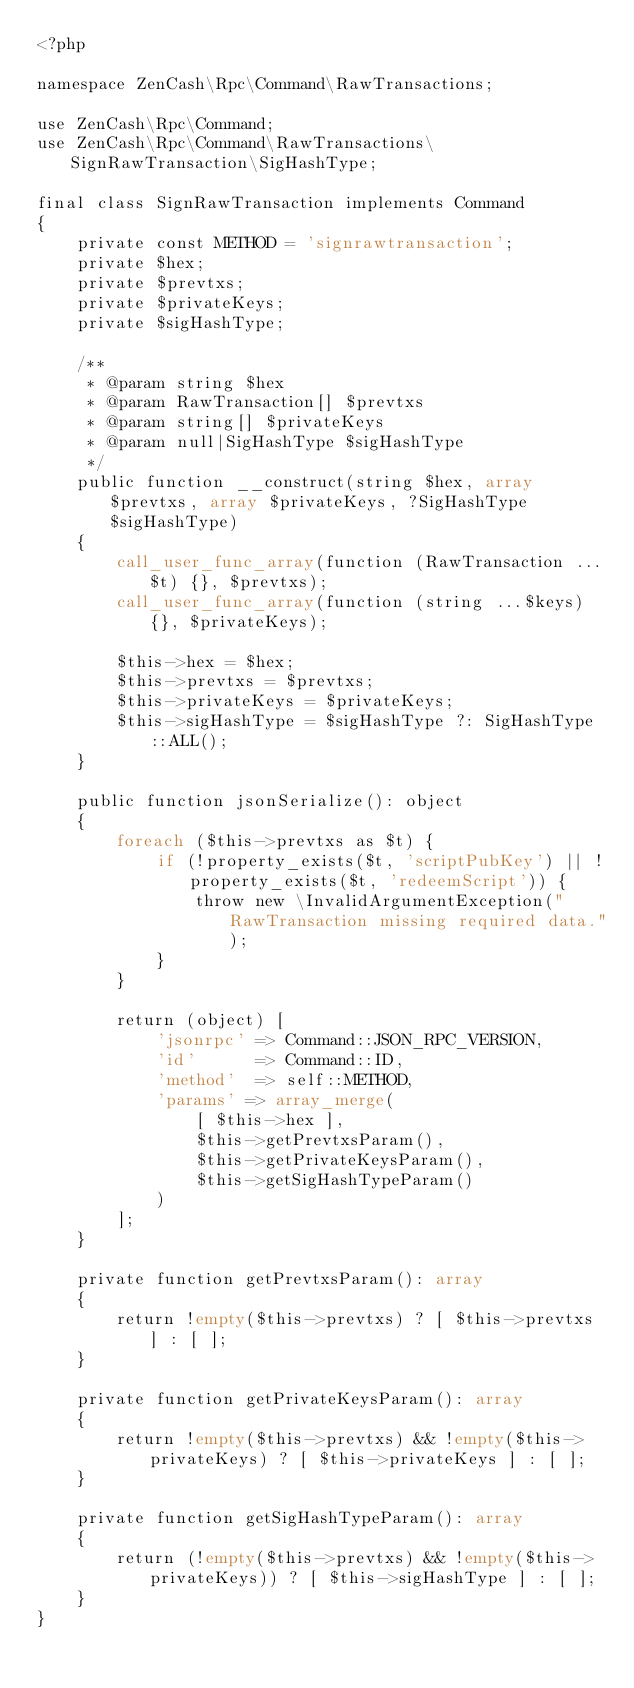Convert code to text. <code><loc_0><loc_0><loc_500><loc_500><_PHP_><?php

namespace ZenCash\Rpc\Command\RawTransactions;

use ZenCash\Rpc\Command;
use ZenCash\Rpc\Command\RawTransactions\SignRawTransaction\SigHashType;

final class SignRawTransaction implements Command
{
    private const METHOD = 'signrawtransaction';
    private $hex;
    private $prevtxs;
    private $privateKeys;
    private $sigHashType;

    /**
     * @param string $hex
     * @param RawTransaction[] $prevtxs
     * @param string[] $privateKeys
     * @param null|SigHashType $sigHashType
     */
    public function __construct(string $hex, array $prevtxs, array $privateKeys, ?SigHashType $sigHashType)
    {
        call_user_func_array(function (RawTransaction ...$t) {}, $prevtxs);
        call_user_func_array(function (string ...$keys) {}, $privateKeys);

        $this->hex = $hex;
        $this->prevtxs = $prevtxs;
        $this->privateKeys = $privateKeys;
        $this->sigHashType = $sigHashType ?: SigHashType::ALL();
    }

    public function jsonSerialize(): object
    {
        foreach ($this->prevtxs as $t) {
            if (!property_exists($t, 'scriptPubKey') || !property_exists($t, 'redeemScript')) {
                throw new \InvalidArgumentException("RawTransaction missing required data.");
            }
        }

        return (object) [
            'jsonrpc' => Command::JSON_RPC_VERSION,
            'id'      => Command::ID,
            'method'  => self::METHOD,
            'params' => array_merge(
                [ $this->hex ],
                $this->getPrevtxsParam(),
                $this->getPrivateKeysParam(),
                $this->getSigHashTypeParam()
            )
        ];
    }

    private function getPrevtxsParam(): array
    {
        return !empty($this->prevtxs) ? [ $this->prevtxs ] : [ ];
    }

    private function getPrivateKeysParam(): array
    {
        return !empty($this->prevtxs) && !empty($this->privateKeys) ? [ $this->privateKeys ] : [ ];
    }

    private function getSigHashTypeParam(): array
    {
        return (!empty($this->prevtxs) && !empty($this->privateKeys)) ? [ $this->sigHashType ] : [ ];
    }
}
</code> 